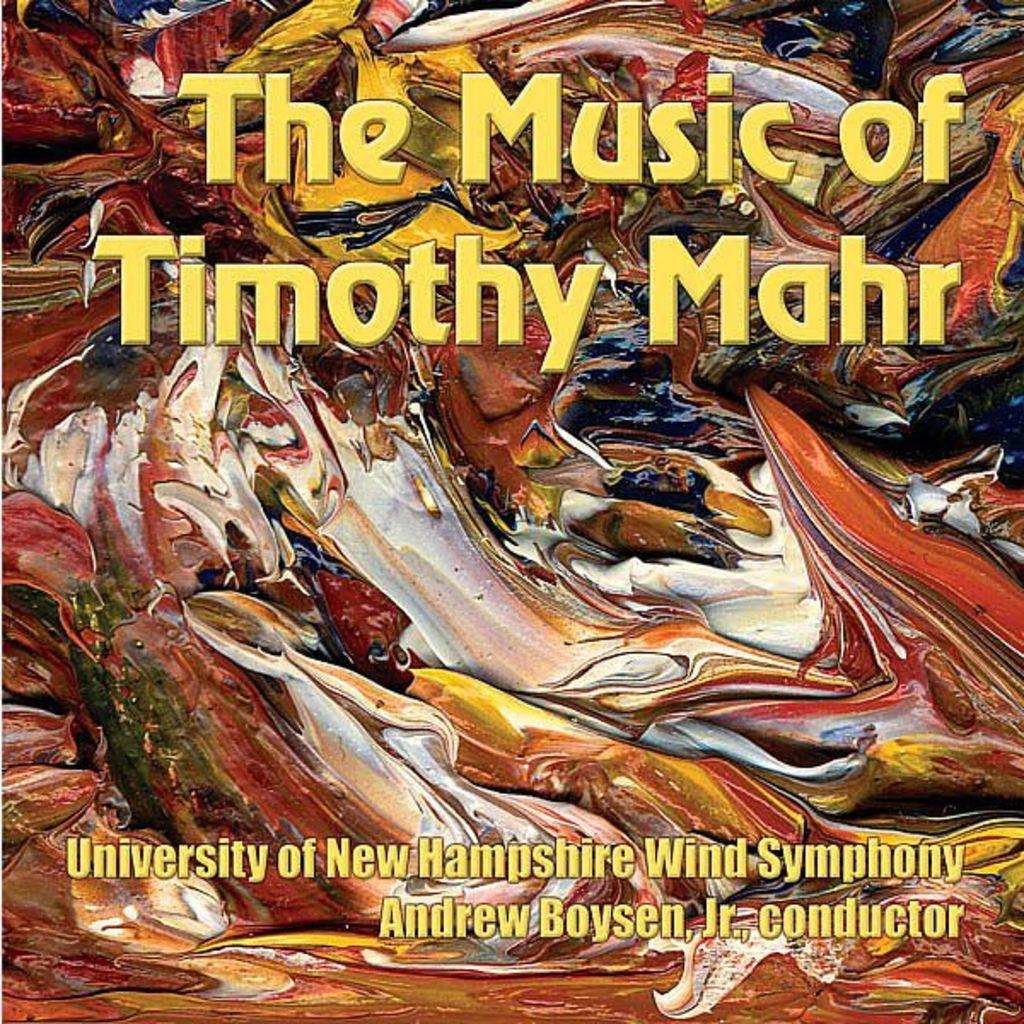<image>
Summarize the visual content of the image. The University of New Hampshire has the music of Timothy Mahr. 